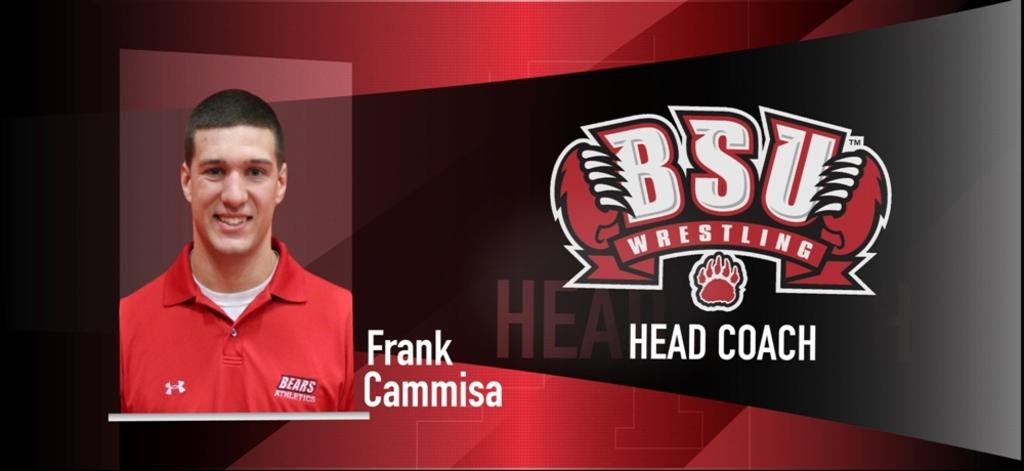<image>
Provide a brief description of the given image. Frank Cammisa is the BSU wrestling head coach. 